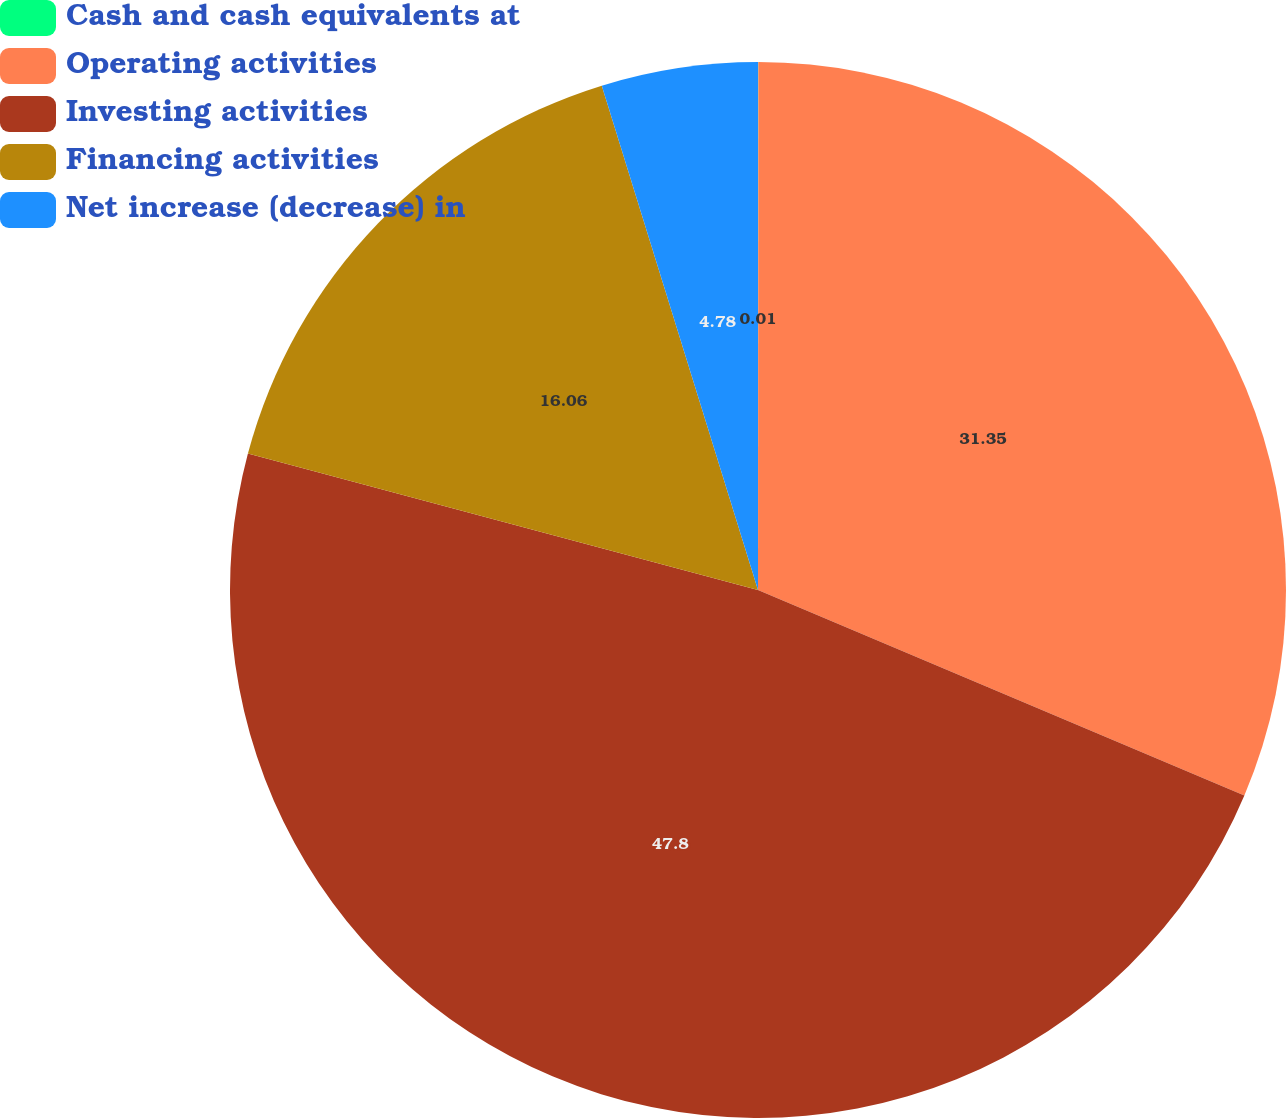<chart> <loc_0><loc_0><loc_500><loc_500><pie_chart><fcel>Cash and cash equivalents at<fcel>Operating activities<fcel>Investing activities<fcel>Financing activities<fcel>Net increase (decrease) in<nl><fcel>0.01%<fcel>31.35%<fcel>47.79%<fcel>16.06%<fcel>4.78%<nl></chart> 